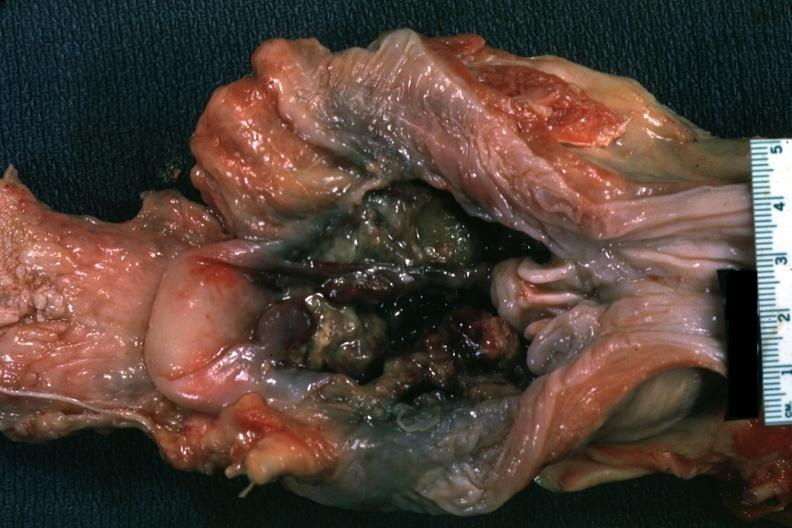how is unopened larynx viewed from hypopharynx mass of tissue?
Answer the question using a single word or phrase. Necrotic 